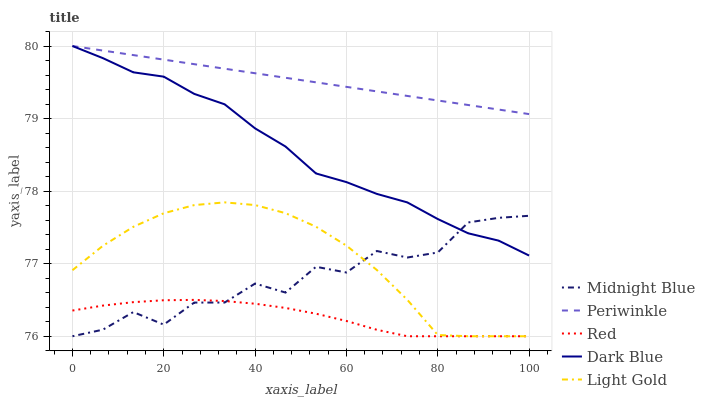Does Light Gold have the minimum area under the curve?
Answer yes or no. No. Does Light Gold have the maximum area under the curve?
Answer yes or no. No. Is Light Gold the smoothest?
Answer yes or no. No. Is Light Gold the roughest?
Answer yes or no. No. Does Periwinkle have the lowest value?
Answer yes or no. No. Does Light Gold have the highest value?
Answer yes or no. No. Is Light Gold less than Periwinkle?
Answer yes or no. Yes. Is Periwinkle greater than Light Gold?
Answer yes or no. Yes. Does Light Gold intersect Periwinkle?
Answer yes or no. No. 